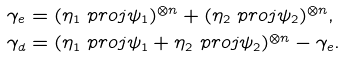<formula> <loc_0><loc_0><loc_500><loc_500>\gamma _ { e } & = ( \eta _ { 1 } \ p r o j { \psi _ { 1 } } ) ^ { \otimes n } + ( \eta _ { 2 } \ p r o j { \psi _ { 2 } } ) ^ { \otimes n } , \\ \gamma _ { d } & = ( \eta _ { 1 } \ p r o j { \psi _ { 1 } } + \eta _ { 2 } \ p r o j { \psi _ { 2 } } ) ^ { \otimes n } - \gamma _ { e } .</formula> 